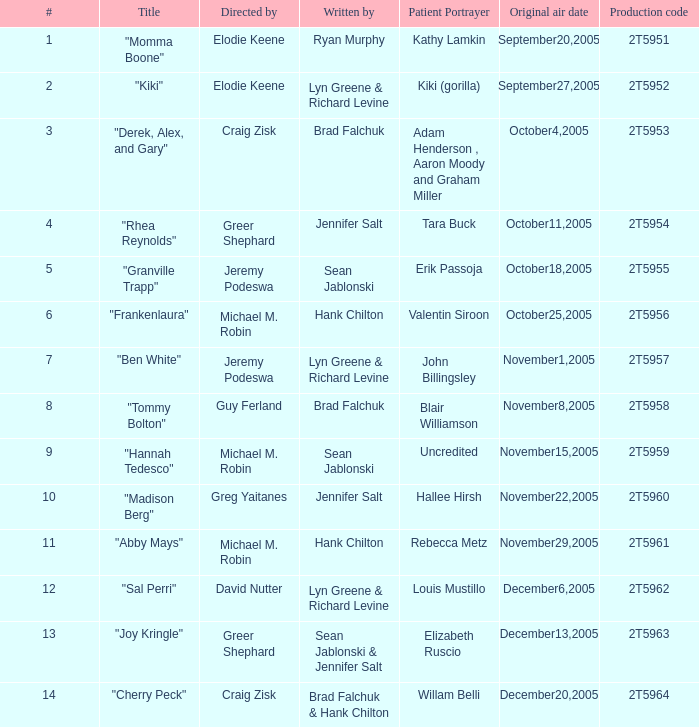Who was the writter for the  episode identified by the production code 2t5954? Jennifer Salt. 